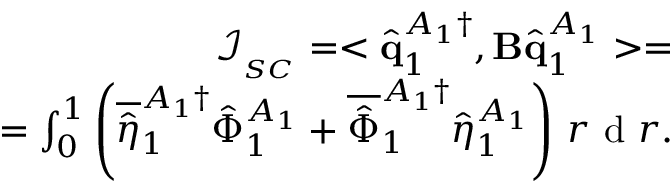Convert formula to latex. <formula><loc_0><loc_0><loc_500><loc_500>\begin{array} { r } { \mathcal { I } _ { _ { S C } } = < \hat { q } _ { 1 } ^ { A _ { 1 } \dagger } , B \hat { q } _ { 1 } ^ { A _ { 1 } } > = } \\ { = \int _ { 0 } ^ { 1 } \left ( \overline { { \hat { \eta } } } _ { 1 } ^ { A _ { 1 } \dagger } \hat { \Phi } _ { 1 } ^ { A _ { 1 } } + \overline { { \hat { \Phi } } } _ { 1 } ^ { A _ { 1 } \dagger } \hat { \eta } _ { 1 } ^ { A _ { 1 } } \right ) \, r d r . } \end{array}</formula> 